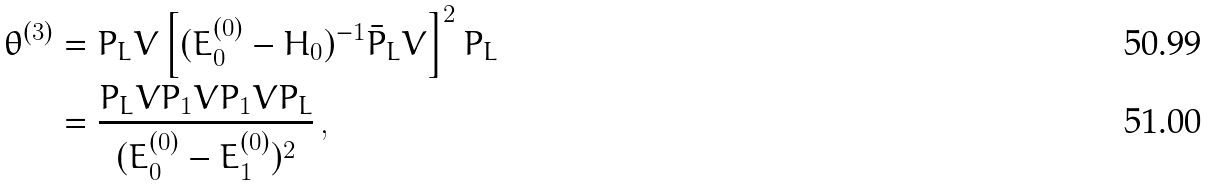<formula> <loc_0><loc_0><loc_500><loc_500>\theta ^ { ( 3 ) } & = P _ { L } V \left [ ( E _ { 0 } ^ { ( 0 ) } - H _ { 0 } ) ^ { - 1 } \bar { P } _ { L } V \right ] ^ { 2 } P _ { L } \\ & = \frac { P _ { L } V P _ { 1 } V P _ { 1 } V P _ { L } } { ( E _ { 0 } ^ { ( 0 ) } - E _ { 1 } ^ { ( 0 ) } ) ^ { 2 } } \, ,</formula> 